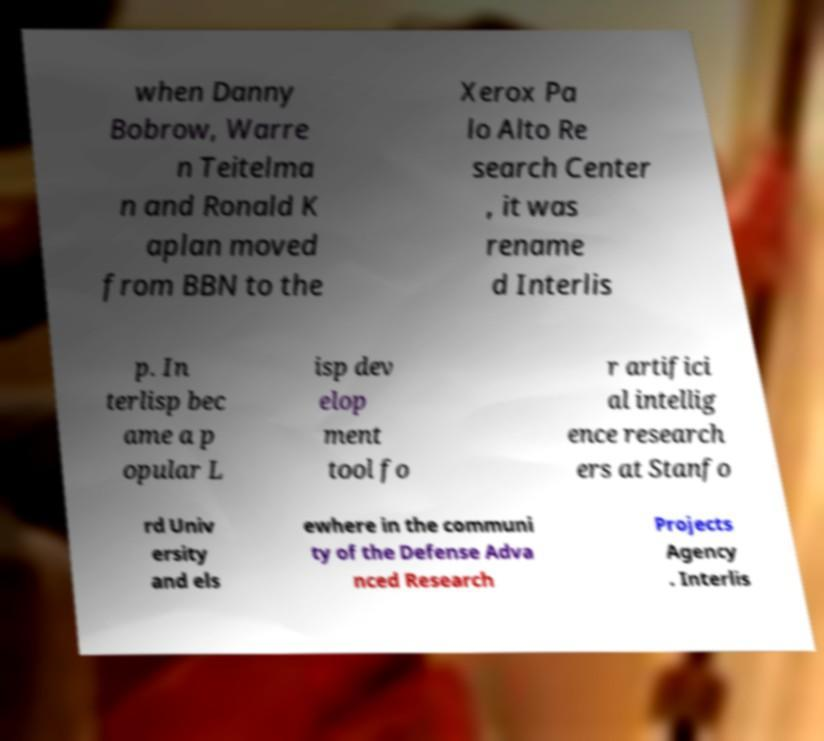Please identify and transcribe the text found in this image. when Danny Bobrow, Warre n Teitelma n and Ronald K aplan moved from BBN to the Xerox Pa lo Alto Re search Center , it was rename d Interlis p. In terlisp bec ame a p opular L isp dev elop ment tool fo r artifici al intellig ence research ers at Stanfo rd Univ ersity and els ewhere in the communi ty of the Defense Adva nced Research Projects Agency . Interlis 